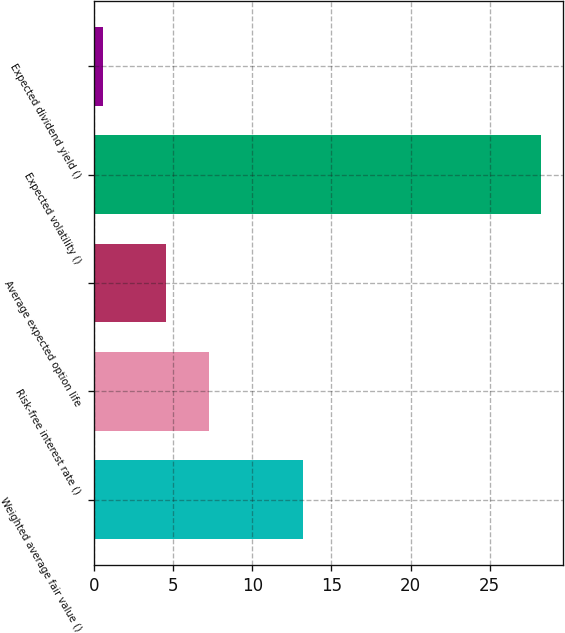<chart> <loc_0><loc_0><loc_500><loc_500><bar_chart><fcel>Weighted average fair value ()<fcel>Risk-free interest rate ()<fcel>Average expected option life<fcel>Expected volatility ()<fcel>Expected dividend yield ()<nl><fcel>13.19<fcel>7.28<fcel>4.51<fcel>28.24<fcel>0.54<nl></chart> 